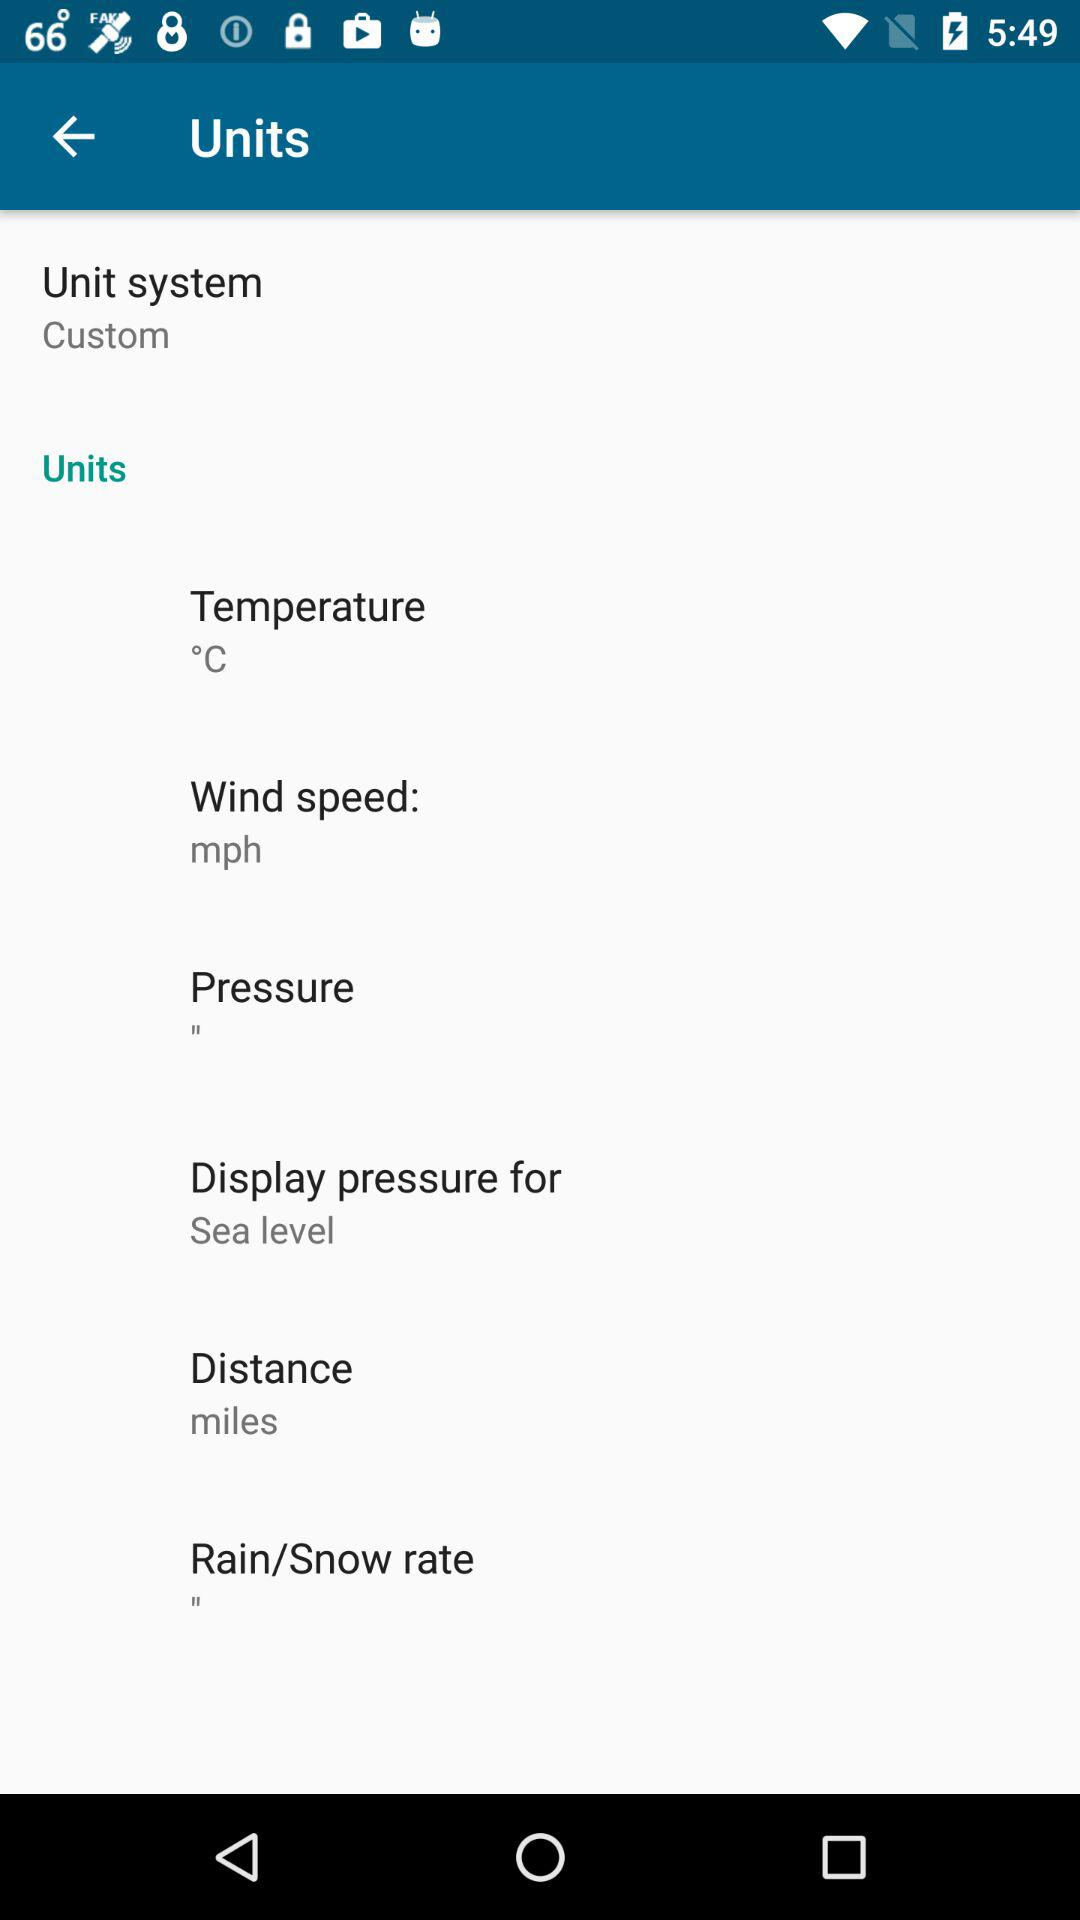What is the unit of pressure shown? The unit of pressure is ". 